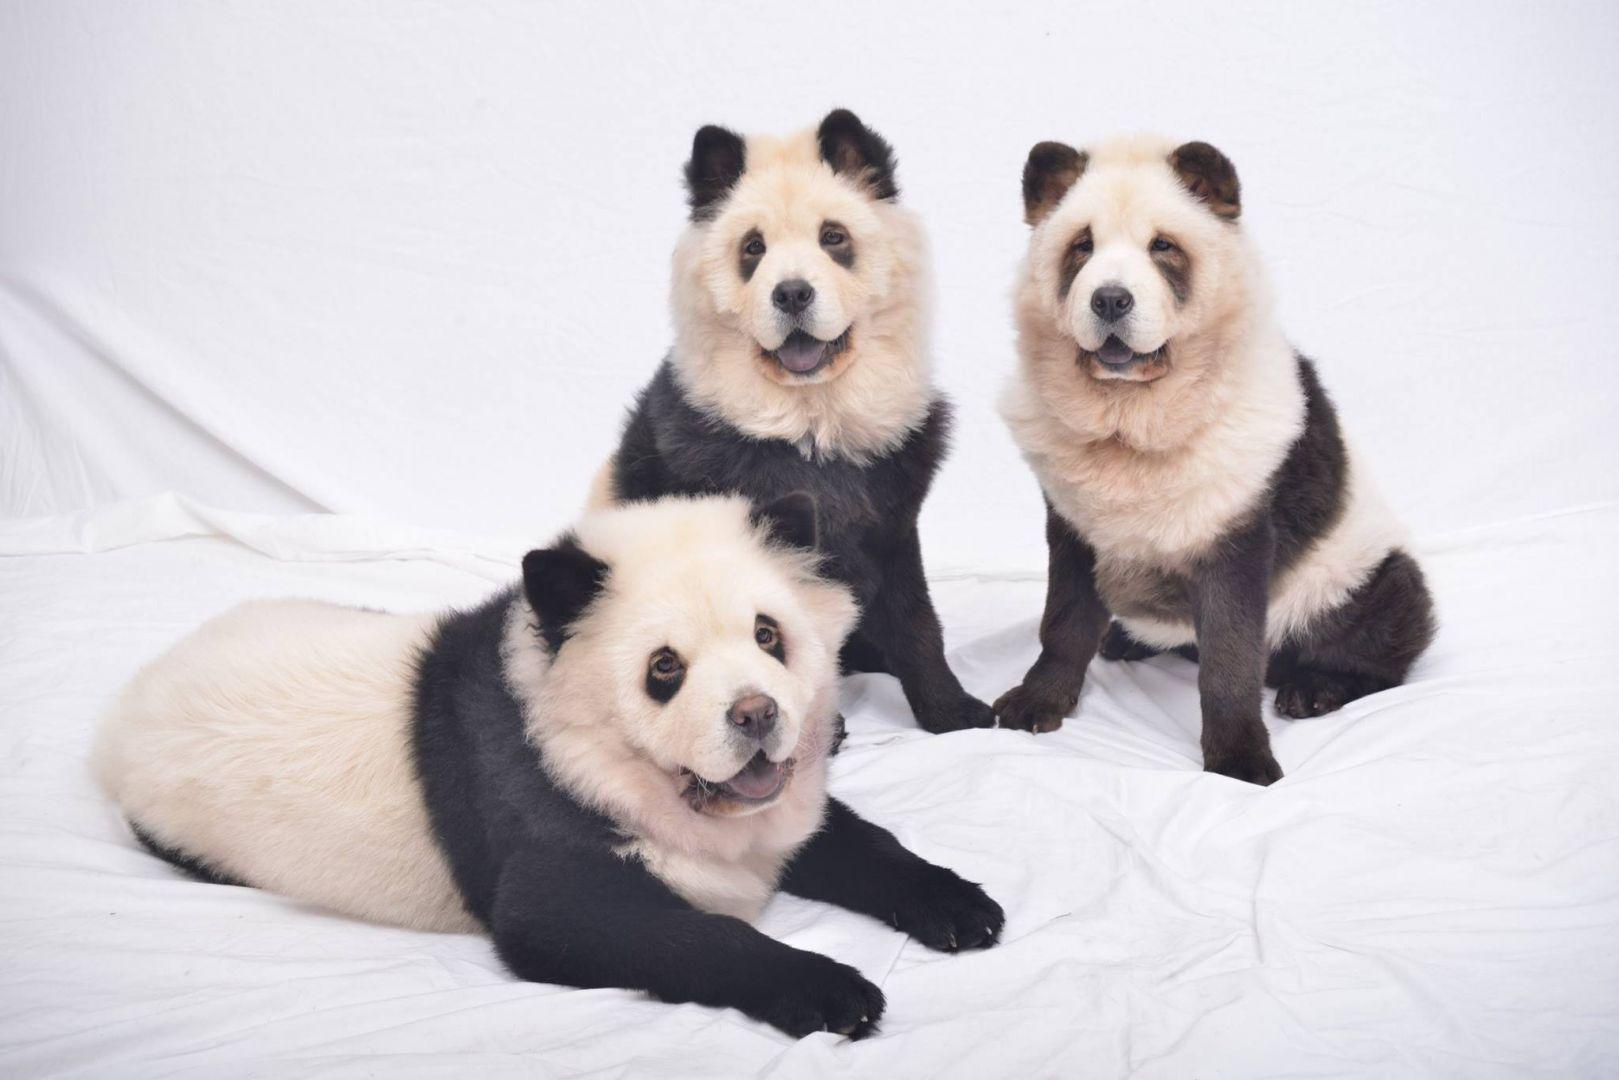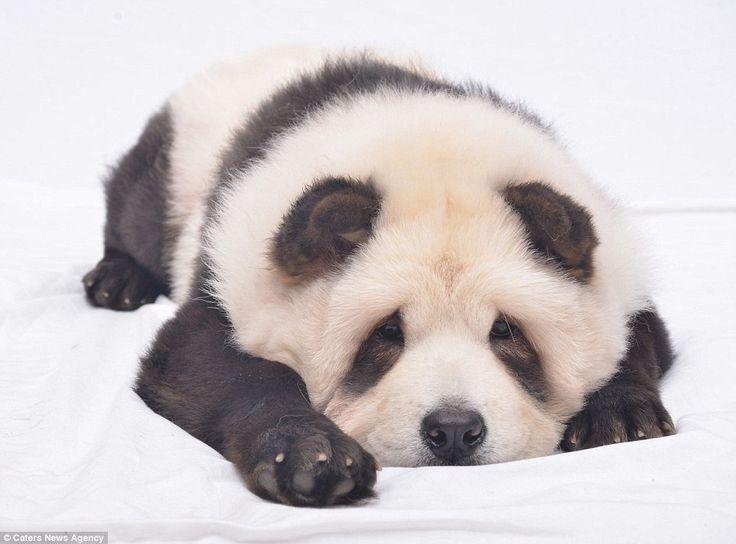The first image is the image on the left, the second image is the image on the right. Considering the images on both sides, is "The left image features a left-turned pale-colored chow standing in front of a person." valid? Answer yes or no. No. The first image is the image on the left, the second image is the image on the right. Assess this claim about the two images: "At least two dogs have their mouths open.". Correct or not? Answer yes or no. Yes. 